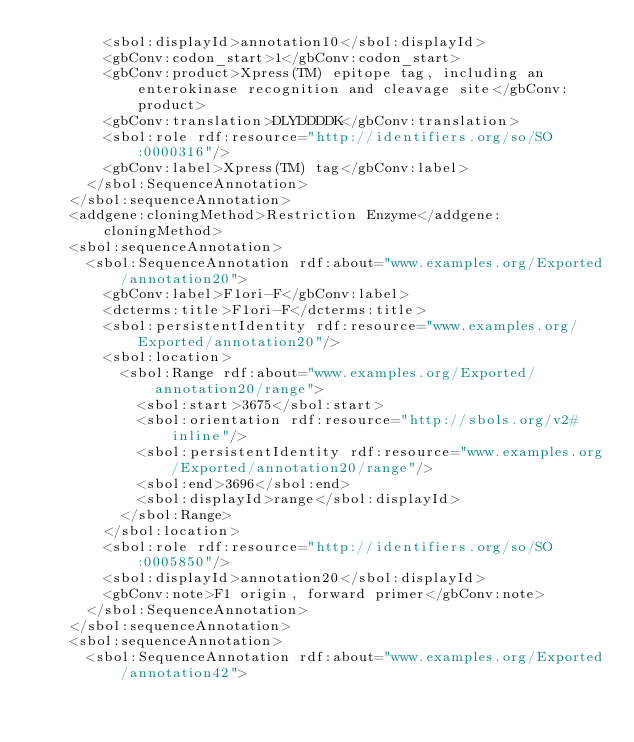<code> <loc_0><loc_0><loc_500><loc_500><_XML_>        <sbol:displayId>annotation10</sbol:displayId>
        <gbConv:codon_start>1</gbConv:codon_start>
        <gbConv:product>Xpress(TM) epitope tag, including an enterokinase recognition and cleavage site</gbConv:product>
        <gbConv:translation>DLYDDDDK</gbConv:translation>
        <sbol:role rdf:resource="http://identifiers.org/so/SO:0000316"/>
        <gbConv:label>Xpress(TM) tag</gbConv:label>
      </sbol:SequenceAnnotation>
    </sbol:sequenceAnnotation>
    <addgene:cloningMethod>Restriction Enzyme</addgene:cloningMethod>
    <sbol:sequenceAnnotation>
      <sbol:SequenceAnnotation rdf:about="www.examples.org/Exported/annotation20">
        <gbConv:label>F1ori-F</gbConv:label>
        <dcterms:title>F1ori-F</dcterms:title>
        <sbol:persistentIdentity rdf:resource="www.examples.org/Exported/annotation20"/>
        <sbol:location>
          <sbol:Range rdf:about="www.examples.org/Exported/annotation20/range">
            <sbol:start>3675</sbol:start>
            <sbol:orientation rdf:resource="http://sbols.org/v2#inline"/>
            <sbol:persistentIdentity rdf:resource="www.examples.org/Exported/annotation20/range"/>
            <sbol:end>3696</sbol:end>
            <sbol:displayId>range</sbol:displayId>
          </sbol:Range>
        </sbol:location>
        <sbol:role rdf:resource="http://identifiers.org/so/SO:0005850"/>
        <sbol:displayId>annotation20</sbol:displayId>
        <gbConv:note>F1 origin, forward primer</gbConv:note>
      </sbol:SequenceAnnotation>
    </sbol:sequenceAnnotation>
    <sbol:sequenceAnnotation>
      <sbol:SequenceAnnotation rdf:about="www.examples.org/Exported/annotation42"></code> 